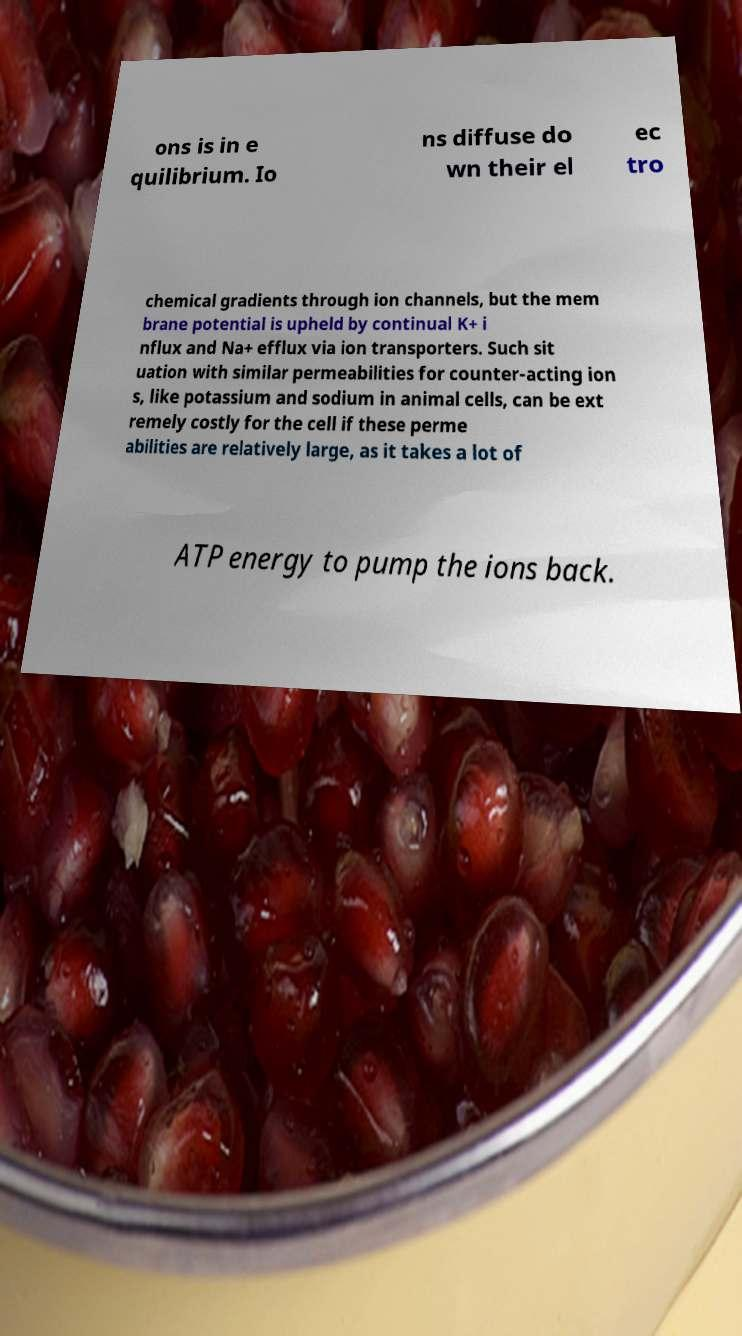Please read and relay the text visible in this image. What does it say? ons is in e quilibrium. Io ns diffuse do wn their el ec tro chemical gradients through ion channels, but the mem brane potential is upheld by continual K+ i nflux and Na+ efflux via ion transporters. Such sit uation with similar permeabilities for counter-acting ion s, like potassium and sodium in animal cells, can be ext remely costly for the cell if these perme abilities are relatively large, as it takes a lot of ATP energy to pump the ions back. 